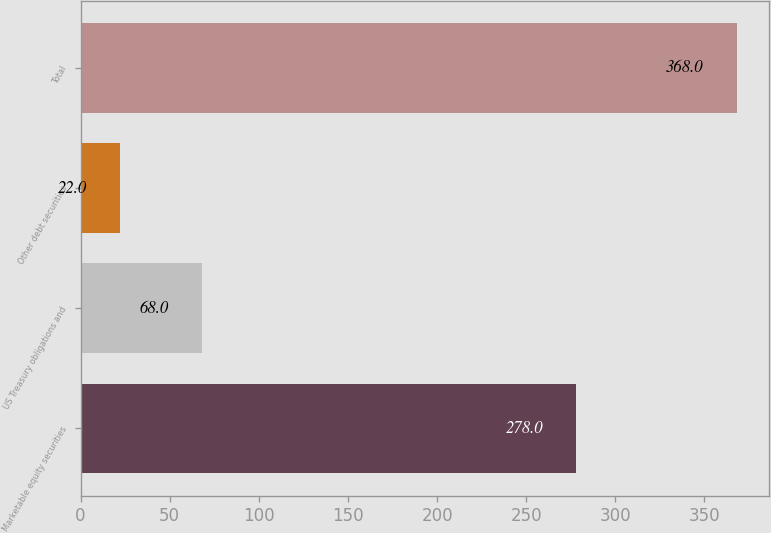Convert chart. <chart><loc_0><loc_0><loc_500><loc_500><bar_chart><fcel>Marketable equity securities<fcel>US Treasury obligations and<fcel>Other debt securities<fcel>Total<nl><fcel>278<fcel>68<fcel>22<fcel>368<nl></chart> 